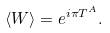<formula> <loc_0><loc_0><loc_500><loc_500>\langle W \rangle = e ^ { i \pi T ^ { A } } .</formula> 